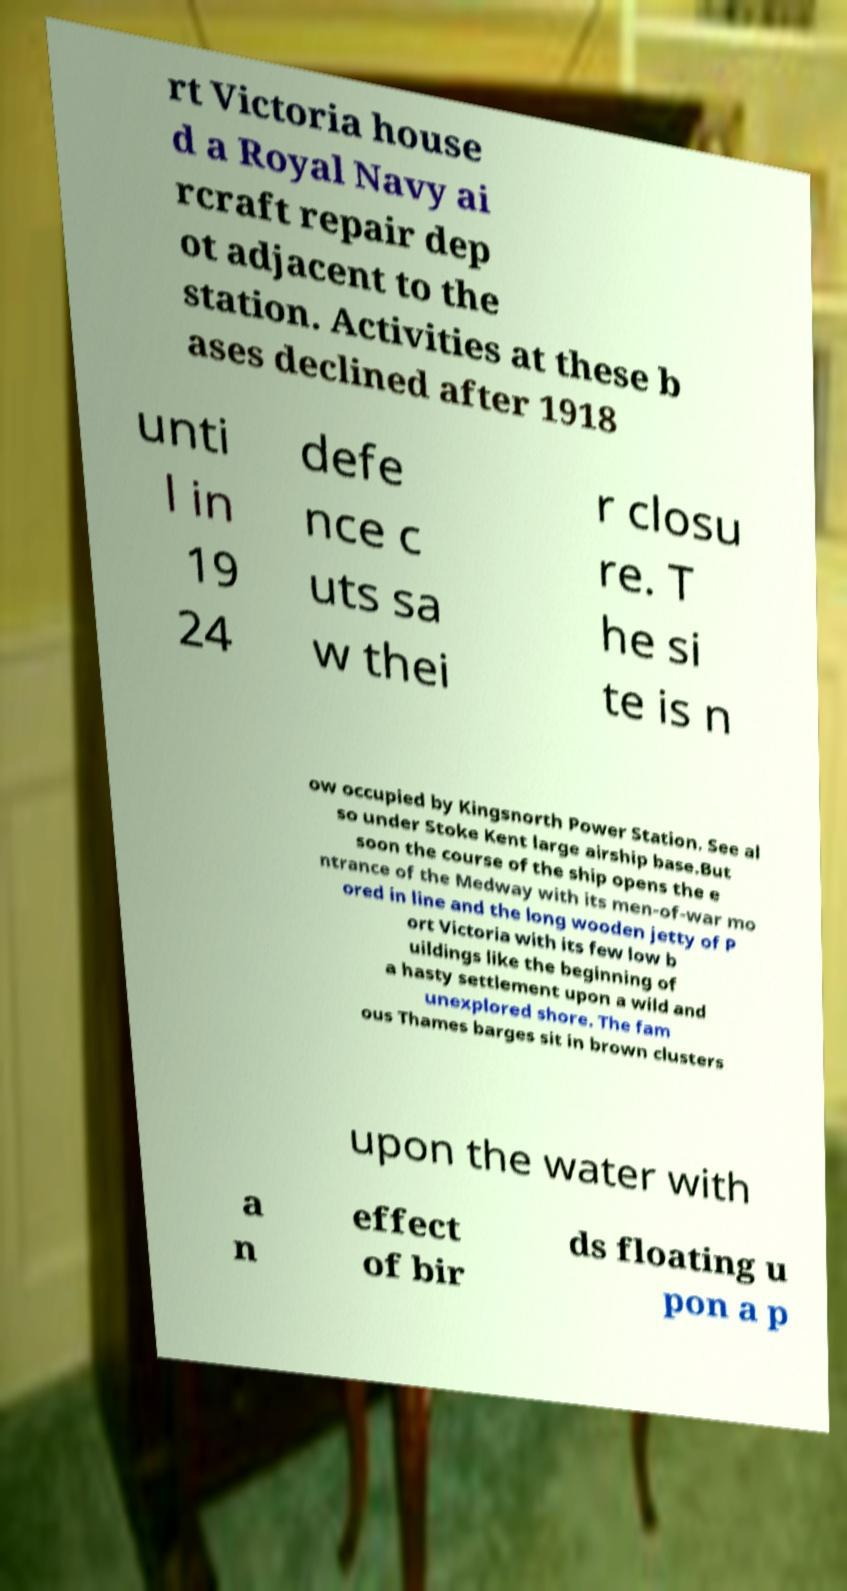Can you read and provide the text displayed in the image?This photo seems to have some interesting text. Can you extract and type it out for me? rt Victoria house d a Royal Navy ai rcraft repair dep ot adjacent to the station. Activities at these b ases declined after 1918 unti l in 19 24 defe nce c uts sa w thei r closu re. T he si te is n ow occupied by Kingsnorth Power Station. See al so under Stoke Kent large airship base.But soon the course of the ship opens the e ntrance of the Medway with its men-of-war mo ored in line and the long wooden jetty of P ort Victoria with its few low b uildings like the beginning of a hasty settlement upon a wild and unexplored shore. The fam ous Thames barges sit in brown clusters upon the water with a n effect of bir ds floating u pon a p 